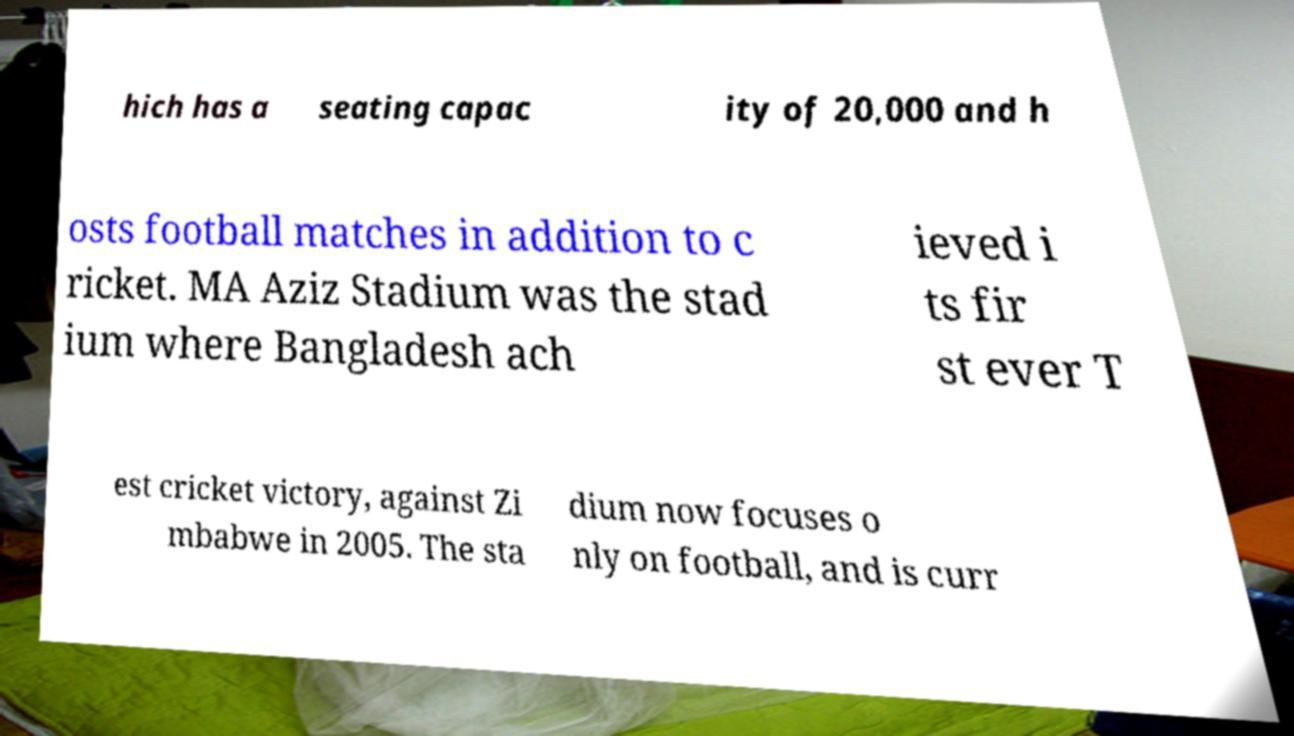Please read and relay the text visible in this image. What does it say? hich has a seating capac ity of 20,000 and h osts football matches in addition to c ricket. MA Aziz Stadium was the stad ium where Bangladesh ach ieved i ts fir st ever T est cricket victory, against Zi mbabwe in 2005. The sta dium now focuses o nly on football, and is curr 